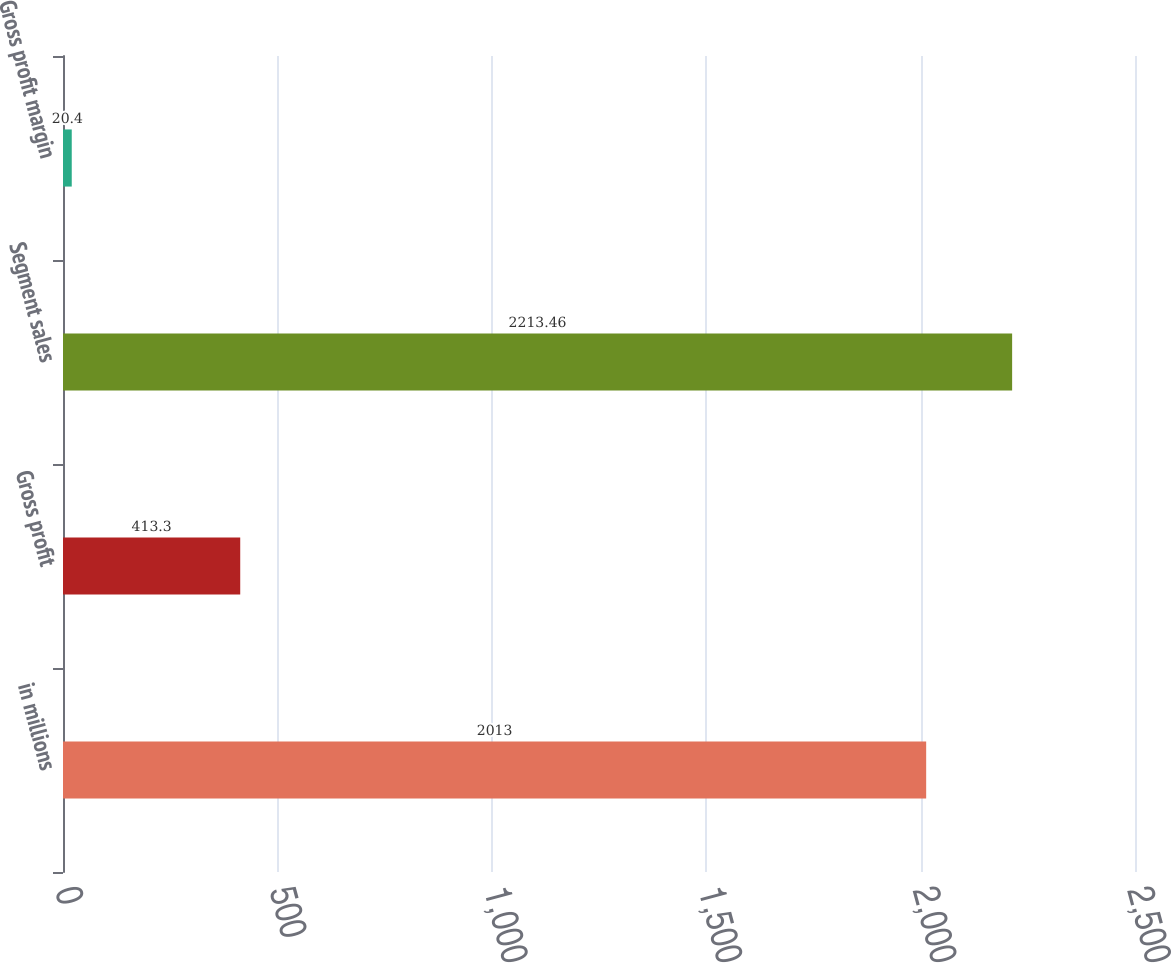Convert chart. <chart><loc_0><loc_0><loc_500><loc_500><bar_chart><fcel>in millions<fcel>Gross profit<fcel>Segment sales<fcel>Gross profit margin<nl><fcel>2013<fcel>413.3<fcel>2213.46<fcel>20.4<nl></chart> 